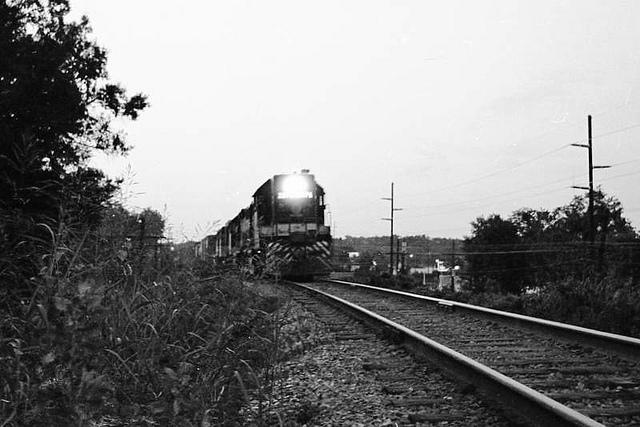Is the sky clear?
Concise answer only. No. Is this a commuter train?
Quick response, please. No. What is coming out of the train?
Give a very brief answer. Light. What are the rails for?
Give a very brief answer. Train. What would happen to a penny left on these rails?
Keep it brief. Flattened. 